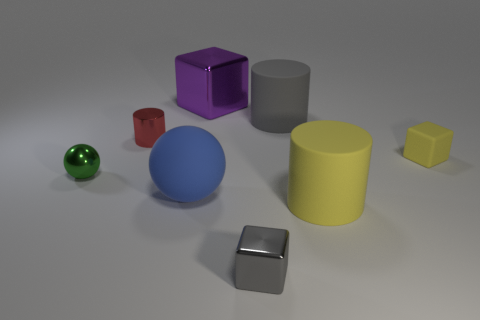The gray cylinder has what size?
Provide a succinct answer. Large. What is the shape of the object that is the same color as the tiny metallic block?
Keep it short and to the point. Cylinder. How many cylinders are either large yellow rubber objects or green metallic things?
Give a very brief answer. 1. Are there the same number of big yellow matte cylinders that are behind the purple object and tiny yellow things that are left of the big gray rubber cylinder?
Your answer should be compact. Yes. What is the size of the rubber object that is the same shape as the green metal thing?
Your answer should be compact. Large. What is the size of the shiny thing that is on the left side of the large matte ball and in front of the tiny yellow cube?
Ensure brevity in your answer.  Small. There is a big cube; are there any large purple metal objects behind it?
Offer a terse response. No. What number of things are tiny green spheres in front of the small metallic cylinder or blue spheres?
Provide a succinct answer. 2. How many rubber cylinders are behind the matte cube in front of the tiny red shiny cylinder?
Give a very brief answer. 1. Is the number of small rubber blocks that are behind the small shiny cylinder less than the number of large metallic cubes in front of the gray rubber cylinder?
Ensure brevity in your answer.  No. 